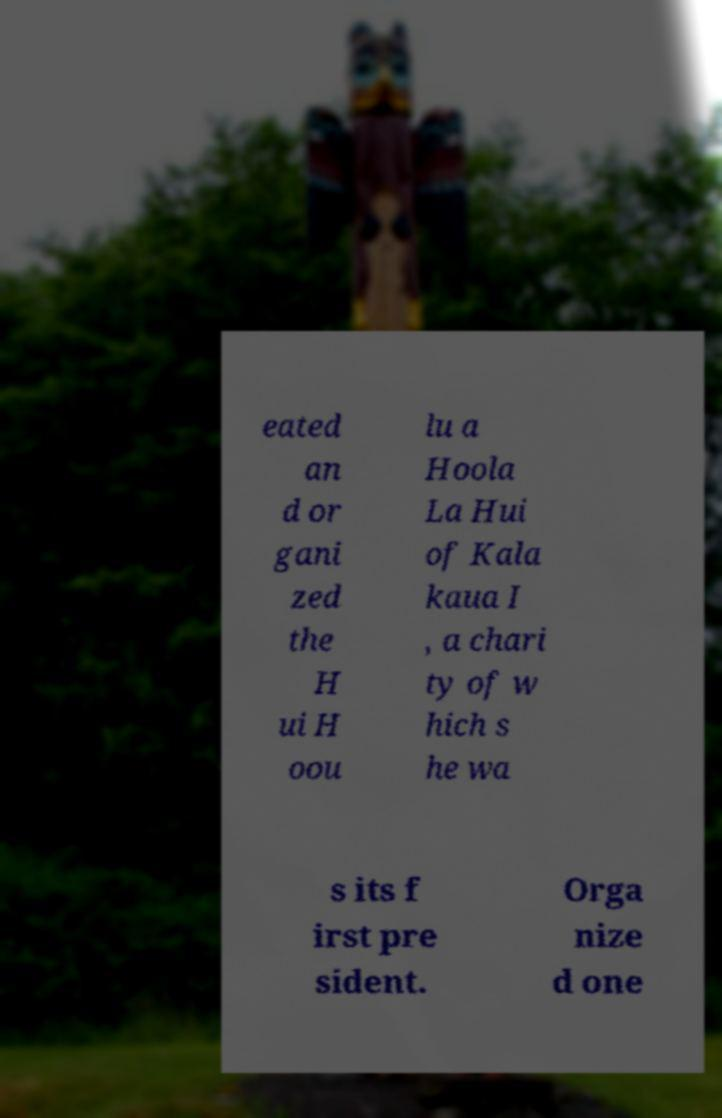Please read and relay the text visible in this image. What does it say? eated an d or gani zed the H ui H oou lu a Hoola La Hui of Kala kaua I , a chari ty of w hich s he wa s its f irst pre sident. Orga nize d one 